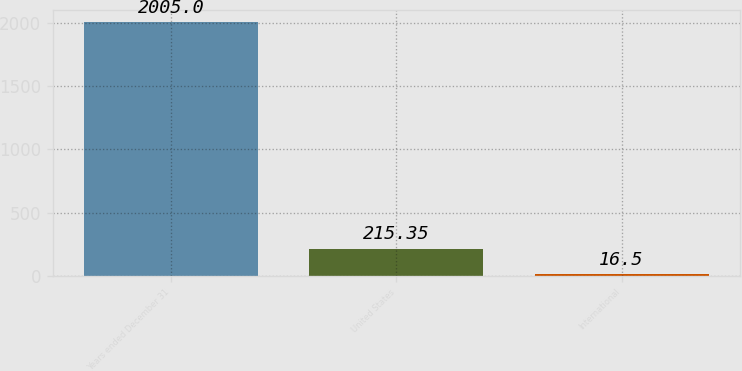Convert chart. <chart><loc_0><loc_0><loc_500><loc_500><bar_chart><fcel>Years ended December 31<fcel>United States<fcel>International<nl><fcel>2005<fcel>215.35<fcel>16.5<nl></chart> 